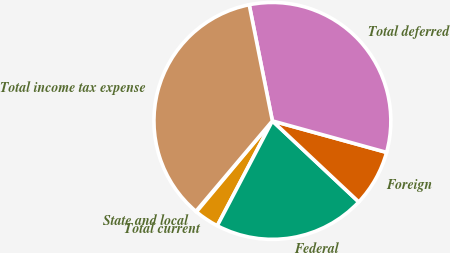<chart> <loc_0><loc_0><loc_500><loc_500><pie_chart><fcel>State and local<fcel>Total current<fcel>Federal<fcel>Foreign<fcel>Total deferred<fcel>Total income tax expense<nl><fcel>0.1%<fcel>3.37%<fcel>20.71%<fcel>7.71%<fcel>32.42%<fcel>35.69%<nl></chart> 